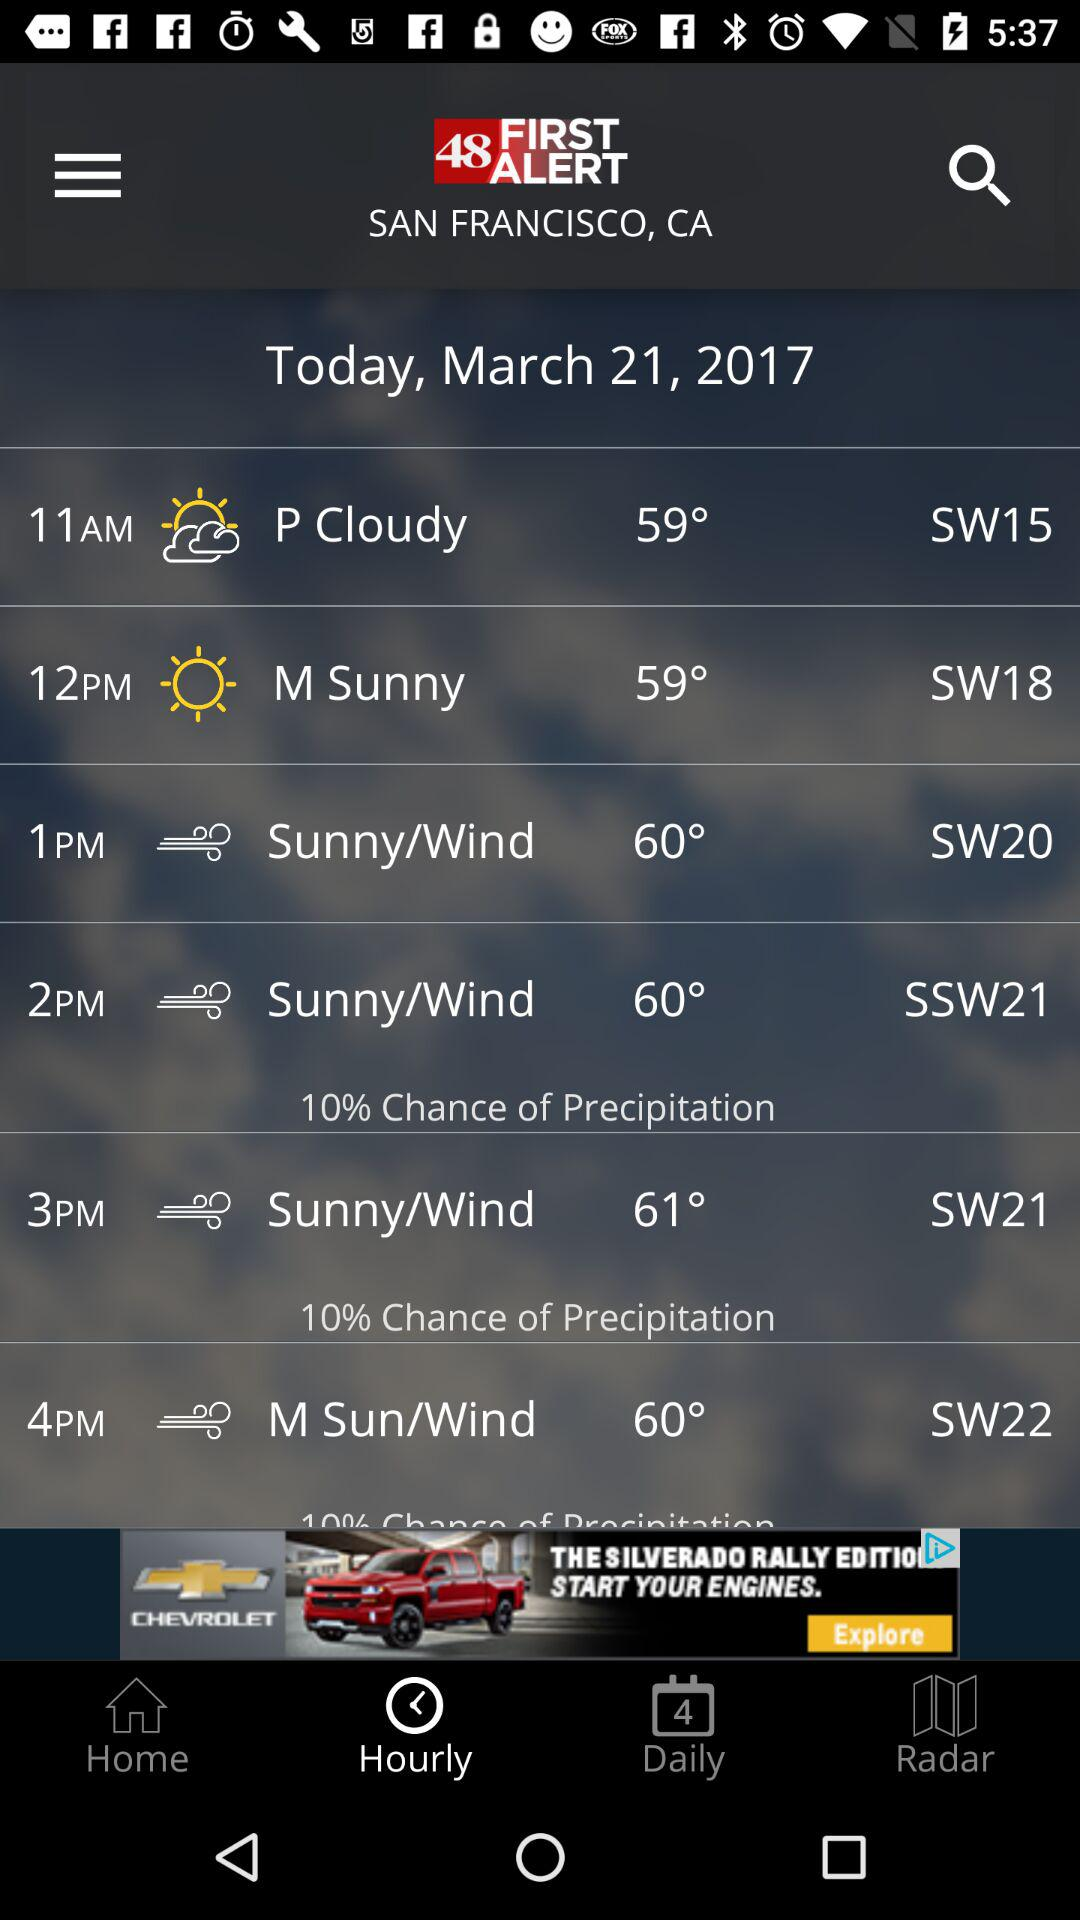What is the chance of precipitation for the 2pm hour?
Answer the question using a single word or phrase. 10% 